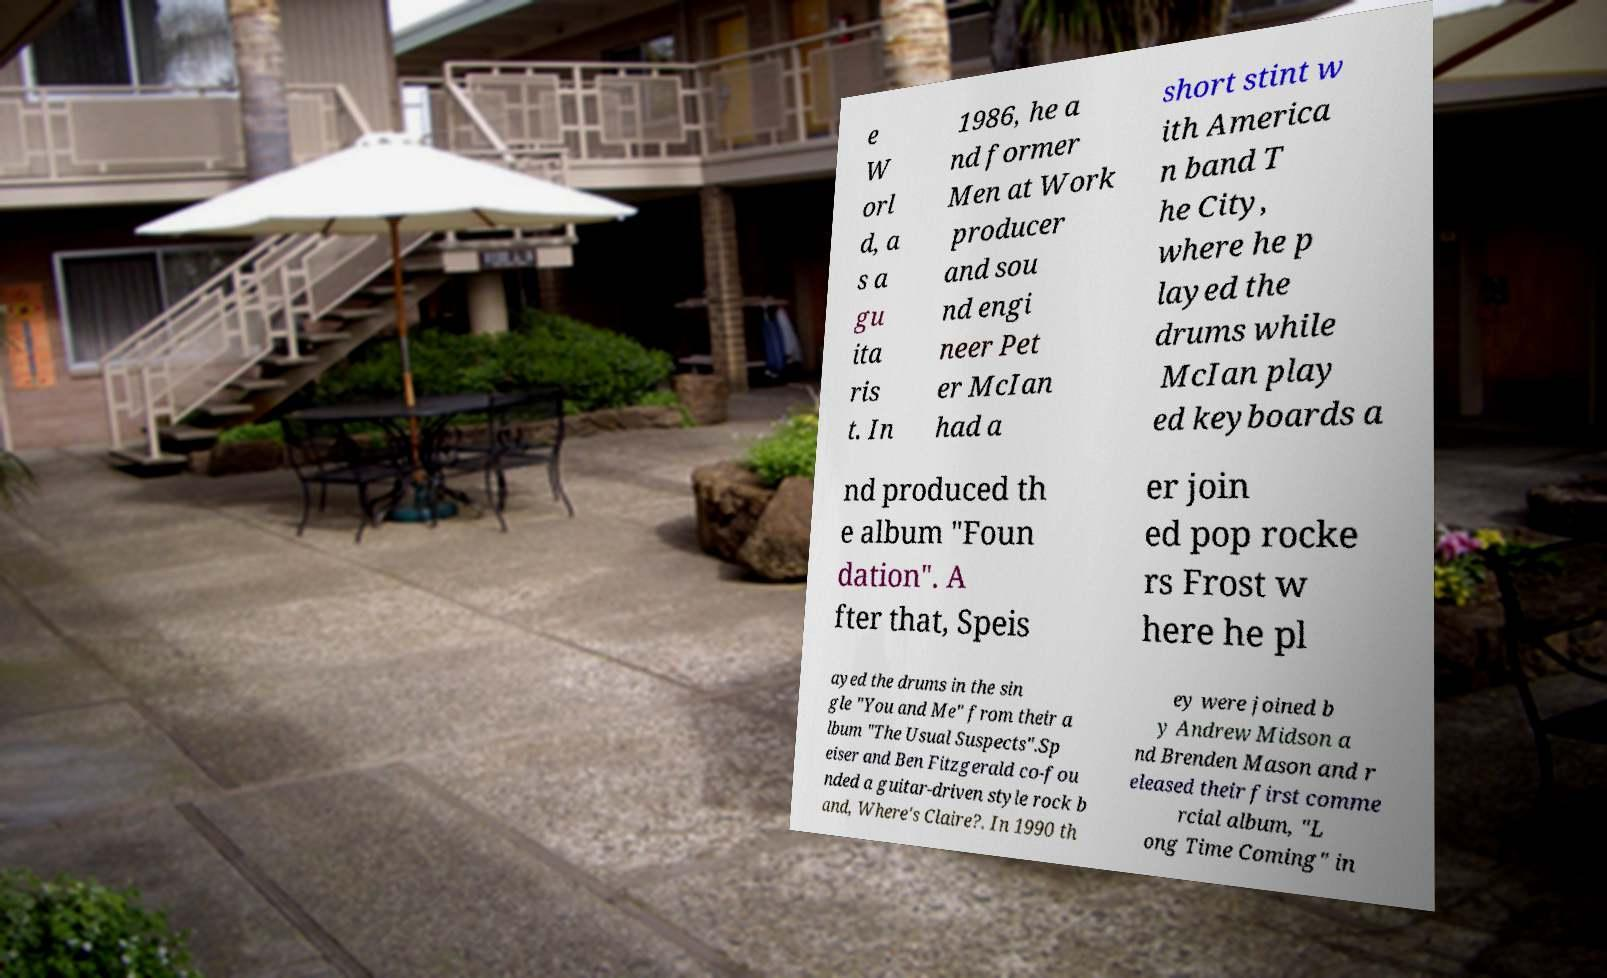What messages or text are displayed in this image? I need them in a readable, typed format. e W orl d, a s a gu ita ris t. In 1986, he a nd former Men at Work producer and sou nd engi neer Pet er McIan had a short stint w ith America n band T he City, where he p layed the drums while McIan play ed keyboards a nd produced th e album "Foun dation". A fter that, Speis er join ed pop rocke rs Frost w here he pl ayed the drums in the sin gle "You and Me" from their a lbum "The Usual Suspects".Sp eiser and Ben Fitzgerald co-fou nded a guitar-driven style rock b and, Where's Claire?. In 1990 th ey were joined b y Andrew Midson a nd Brenden Mason and r eleased their first comme rcial album, "L ong Time Coming" in 